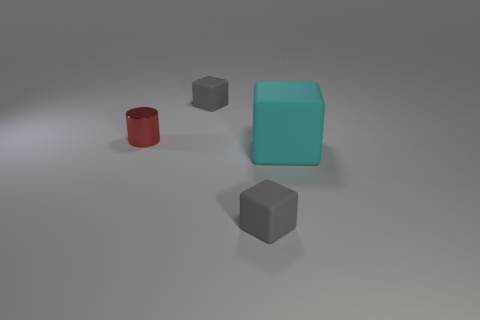Subtract all blocks. How many objects are left? 1 Subtract 1 cylinders. How many cylinders are left? 0 Subtract all yellow cubes. Subtract all cyan balls. How many cubes are left? 3 Subtract all cyan cylinders. How many cyan blocks are left? 1 Subtract all tiny red cylinders. Subtract all small cubes. How many objects are left? 1 Add 2 large cyan things. How many large cyan things are left? 3 Add 2 small rubber blocks. How many small rubber blocks exist? 4 Add 3 tiny purple rubber cubes. How many objects exist? 7 Subtract all gray cubes. How many cubes are left? 1 Subtract all small gray blocks. How many blocks are left? 1 